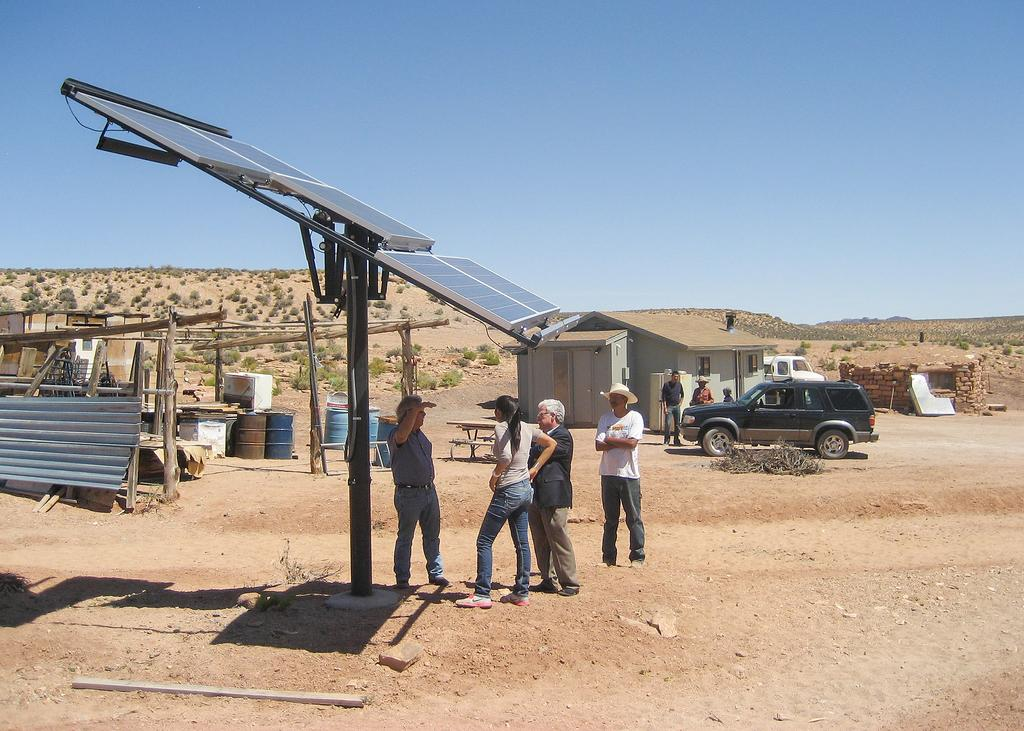What are the persons in the image standing under? The persons in the image are standing under solar panels. What can be seen in the background of the image? There is a building, a car, people, a truck, land, and the sky visible in the background of the image. What is the purpose of the desk in the image? There is no desk present in the image, so it is not possible to determine its purpose. What discovery was made by the people in the image? There is no indication of a discovery in the image; it simply shows persons standing under solar panels and various elements in the background. 